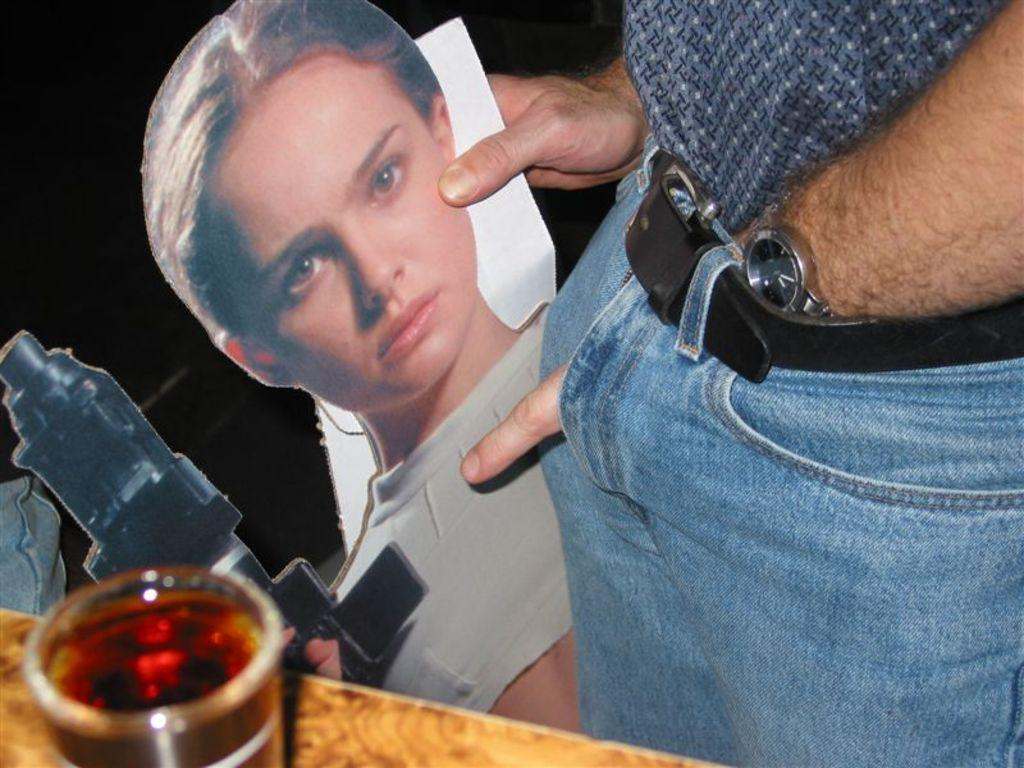What is the person in the image holding? The person in the image is holding a photograph. What is shown in the photograph? The photograph depicts a man holding a gun. What else can be seen in the image besides the person and the photograph? There is a glass of liquid on a surface in the image. How many birds are sitting on the person's thumb in the image? There are no birds or thumbs visible in the image. What type of party is being depicted in the image? There is no party depicted in the image; it features a person holding a photograph of a man holding a gun. 